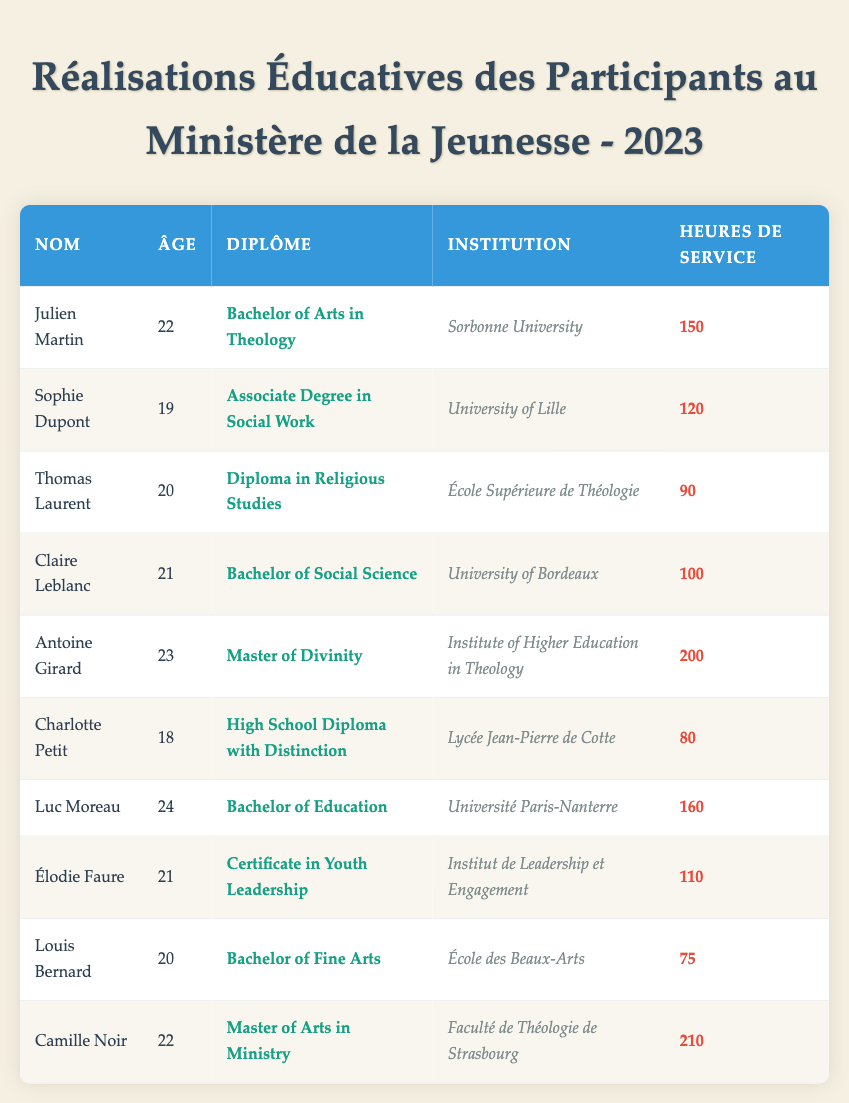What educational achievement does Antoine Girard hold? Referring to the table, under the row for Antoine Girard, the educational achievement is stated as "Master of Divinity."
Answer: Master of Divinity What was the age of the participant who completed the Associate Degree in Social Work? By looking at the row for Sophie Dupont, it is noted that her age is 19, and she completed the Associate Degree in Social Work.
Answer: 19 How many community service hours did the participant with the highest degree complete? Antoine Girard, who holds a Master of Divinity, completed 200 community service hours, which is the highest in the table since others have fewer hours.
Answer: 200 Is there a participant who has a High School Diploma with Distinction? Charlotte Petit is listed in the table with the educational achievement of "High School Diploma with Distinction," confirming that such a participant exists.
Answer: Yes What is the total number of community service hours completed by all participants? Summing up all community service hours: 150 + 120 + 90 + 100 + 200 + 80 + 160 + 110 + 75 + 210 gives a total of 1,675.
Answer: 1675 Which institution did the participant with the Bachelor of Fine Arts attend? Referring to the row for Louis Bernard, he attended "École des Beaux-Arts" as indicated in the table.
Answer: École des Beaux-Arts How many total participants completed their educational achievements in 2023? The table lists a total of 10 participants, each one of them completed their educational achievement in 2023, confirming there are 10.
Answer: 10 Which participant contributed the least number of community service hours? Looking through the table, Louis Bernard only completed 75 community service hours, which is the least among all participants listed.
Answer: 75 Among the participants, who has the highest age, and what is that age? The participant with the highest age is Luc Moreau, who is 24 years old, as observed in the corresponding row.
Answer: 24 What is the average number of community service hours among participants? Adding the total hours (1,675) and dividing by the number of participants (10), the average community service hours is 1,675/10 = 167.5.
Answer: 167.5 